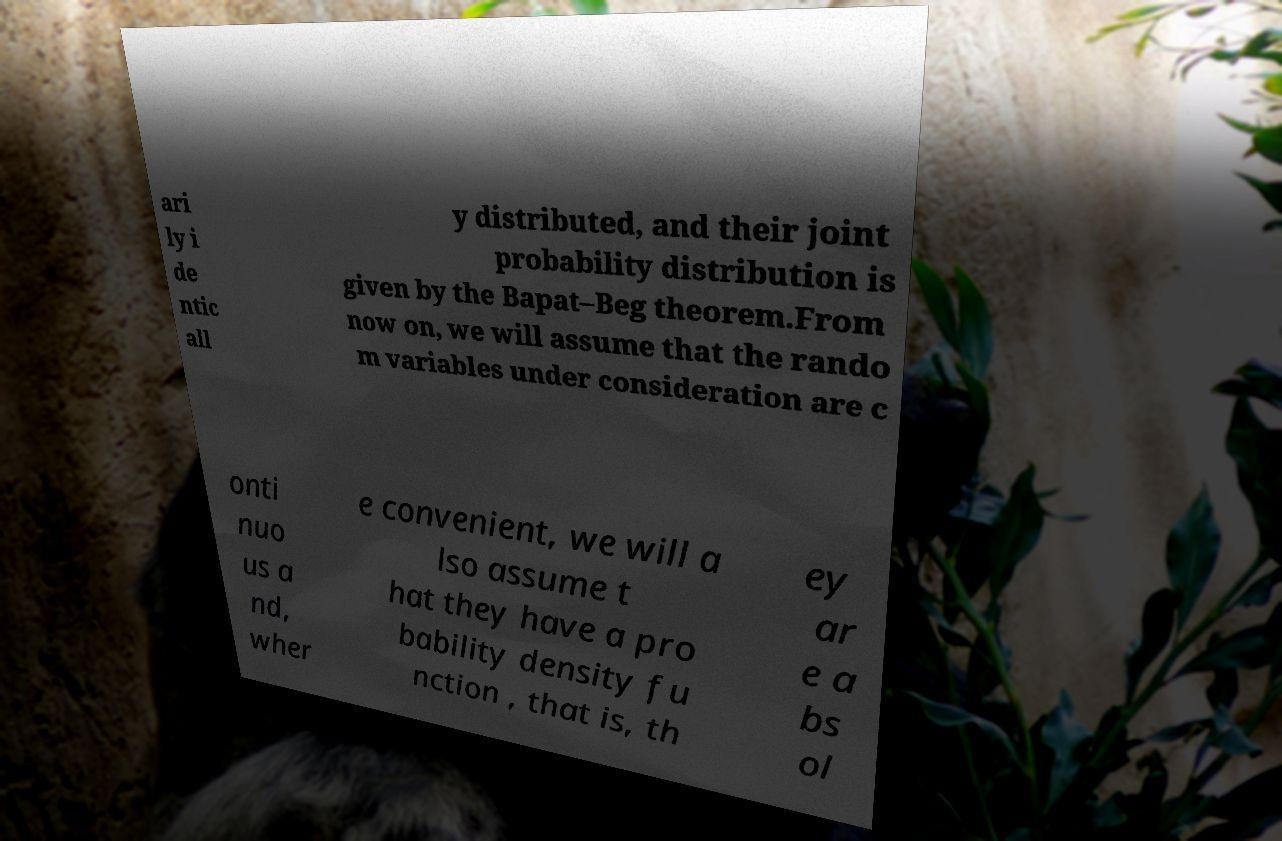Could you assist in decoding the text presented in this image and type it out clearly? ari ly i de ntic all y distributed, and their joint probability distribution is given by the Bapat–Beg theorem.From now on, we will assume that the rando m variables under consideration are c onti nuo us a nd, wher e convenient, we will a lso assume t hat they have a pro bability density fu nction , that is, th ey ar e a bs ol 